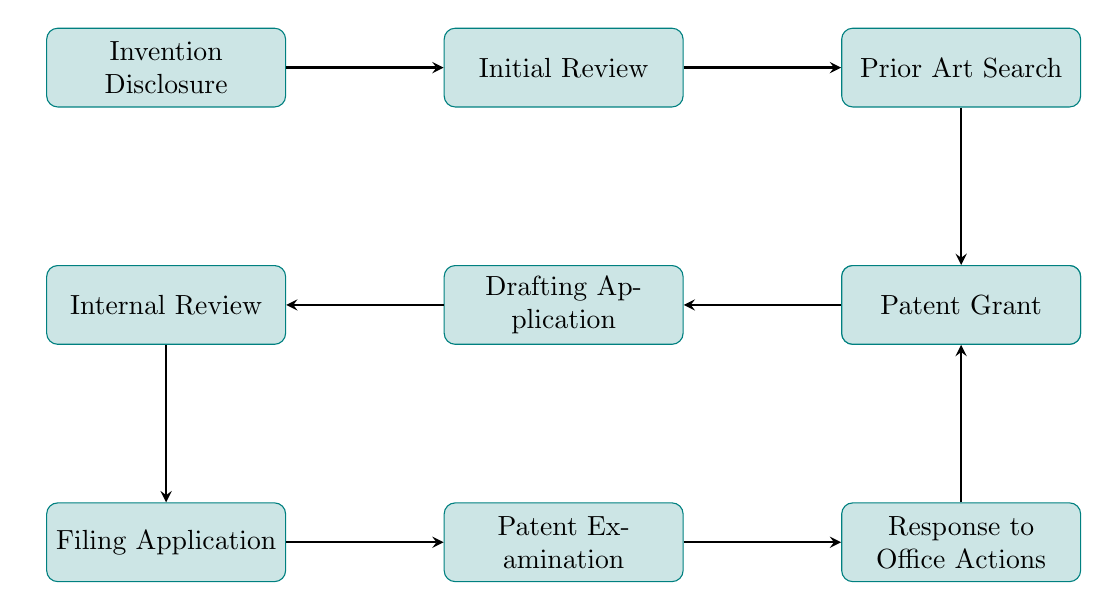What is the first step in the patent filing process? The diagram shows the nodes leading from one to another. The first node listed is "Invention Disclosure," indicating that this is the starting point of the process.
Answer: Invention Disclosure How many nodes are present in the diagram? By counting the distinct labeled processes in the diagram, we find a total of ten nodes related to the patent filing process.
Answer: 10 What follows the "Initial Review"? The flow of the diagram indicates that after "Initial Review," the next step is "Prior Art Search." This can be observed from the directional arrow pointing from "Initial Review" to "Prior Art Search."
Answer: Prior Art Search Which step is directly before the "Patent Grant"? The diagram shows an arrow pointing from "Response to Office Actions" directly to "Patent Grant," making it the immediate preceding step.
Answer: Response to Office Actions What action takes place during node six? Referring to the label in node six, the action taking place during this step is "Internal Review," which is the process of reviewing the draft application by internal stakeholders.
Answer: Internal Review How many edges connect the nodes in the diagram? Evaluating each connection shown in the diagram reveals that there are nine edges that represent transitions from one process to another in the patent filing workflow.
Answer: 9 What is necessary before "Filing the Patent Application"? The diagram clearly indicates that the step of "Drafting the Patent Application" must take place before the filing can occur, as represented by the arrow leading from "Drafting the Patent Application" to "Filing Application."
Answer: Drafting the Patent Application Which step involves responding to the patent examiner's actions? The diagram specifically highlights "Response to Office Actions" as the step that deals with addressing any objections or requests from the patent examiner after the initial exam.
Answer: Response to Office Actions In what order does the "Prior Art Search" come in the process? Analyzing the sequence of steps, "Prior Art Search" is the third step in the process, following "Initial Review" and preceding "Assessment."
Answer: Third 